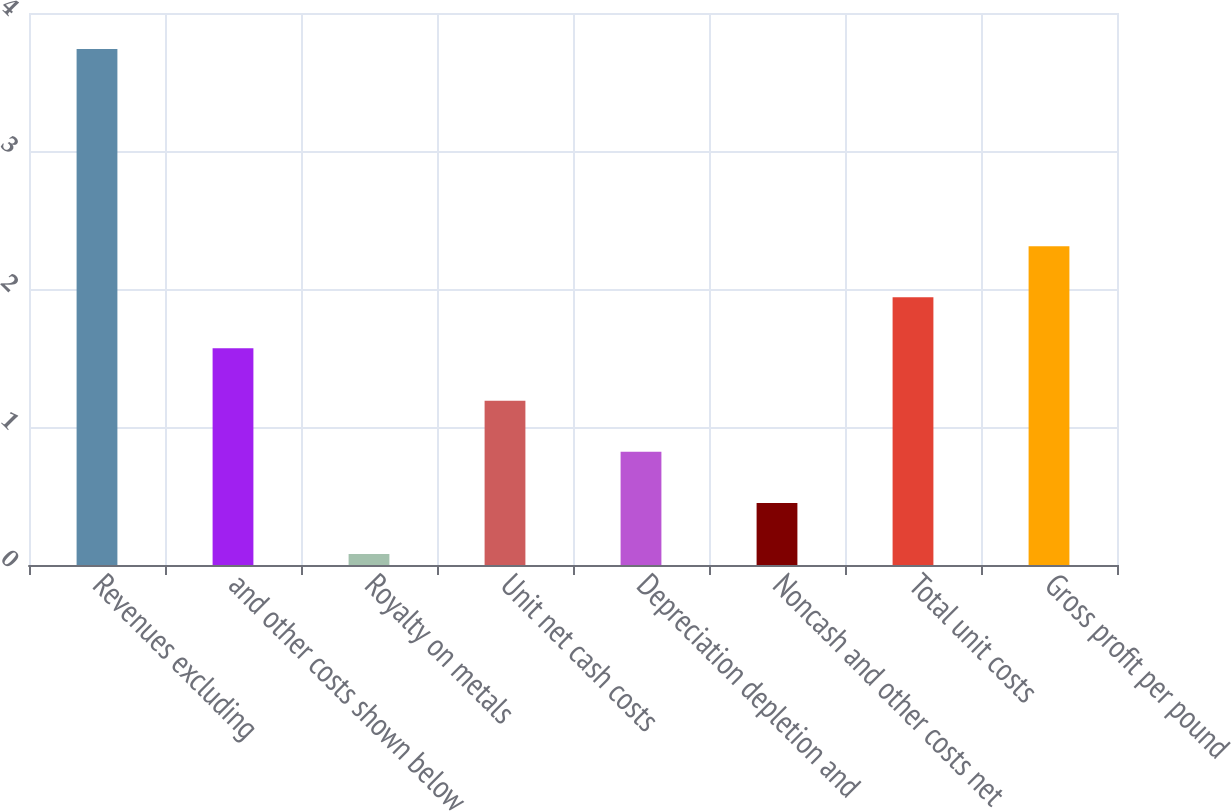Convert chart. <chart><loc_0><loc_0><loc_500><loc_500><bar_chart><fcel>Revenues excluding<fcel>and other costs shown below<fcel>Royalty on metals<fcel>Unit net cash costs<fcel>Depreciation depletion and<fcel>Noncash and other costs net<fcel>Total unit costs<fcel>Gross profit per pound<nl><fcel>3.74<fcel>1.57<fcel>0.08<fcel>1.19<fcel>0.82<fcel>0.45<fcel>1.94<fcel>2.31<nl></chart> 